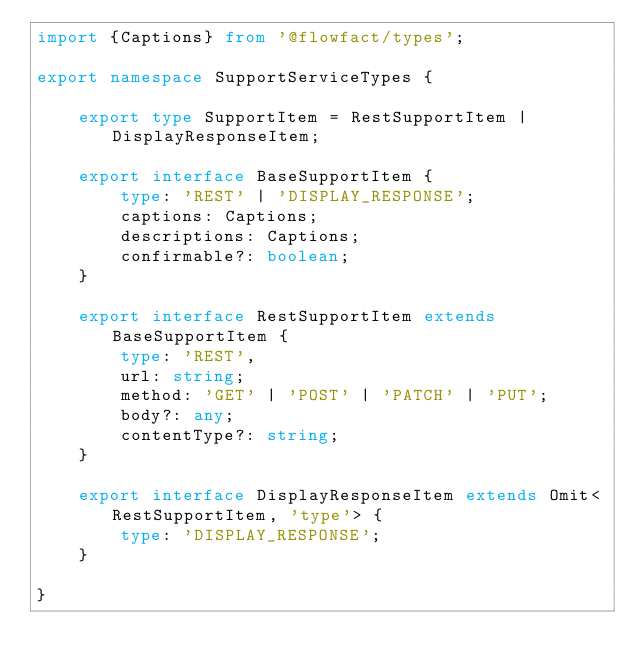Convert code to text. <code><loc_0><loc_0><loc_500><loc_500><_TypeScript_>import {Captions} from '@flowfact/types';

export namespace SupportServiceTypes {

    export type SupportItem = RestSupportItem | DisplayResponseItem;

    export interface BaseSupportItem {
        type: 'REST' | 'DISPLAY_RESPONSE';
        captions: Captions;
        descriptions: Captions;
        confirmable?: boolean;
    }

    export interface RestSupportItem extends BaseSupportItem {
        type: 'REST',
        url: string;
        method: 'GET' | 'POST' | 'PATCH' | 'PUT';
        body?: any;
        contentType?: string;
    }

    export interface DisplayResponseItem extends Omit<RestSupportItem, 'type'> {
        type: 'DISPLAY_RESPONSE';
    }

}</code> 